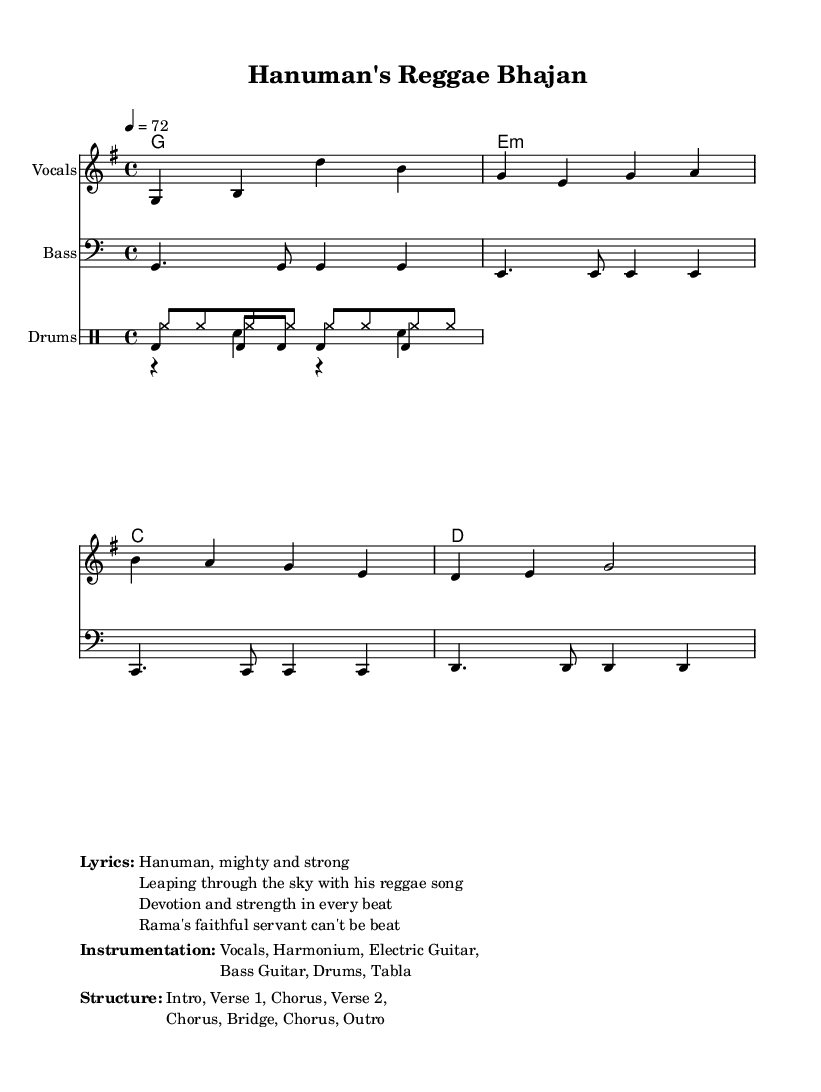What is the key signature of this music? The key signature is G major, which has one sharp (F#). It is indicated at the beginning of the staff in the sheet music.
Answer: G major What is the time signature of this music? The time signature is 4/4, meaning there are four beats in each measure and the quarter note gets one beat. This can be seen at the beginning of the music notation.
Answer: 4/4 What is the tempo marking of this piece? The tempo marking is 72 beats per minute, which is indicated in the tempo text at the top of the score. This shows the speed at which the piece should be played.
Answer: 72 How many measures are in the melody line? The melody line consists of 8 measures, as indicated by counting the distinct groupings of notes and rests in the melody section of the score.
Answer: 8 What type of instruments are used in this arrangement? The arrangement features vocals, harmonium, electric guitar, bass guitar, drums, and tabla. This is listed in the markup section below the score, detailing the instrumentation.
Answer: Vocals, Harmonium, Electric Guitar, Bass Guitar, Drums, Tabla What is the structure of the piece? The structure consists of an Intro, two Verses, a Chorus repeated multiple times, and an Outro. This is outlined in the markup section, which organizes the progression of the piece.
Answer: Intro, Verse 1, Chorus, Verse 2, Chorus, Bridge, Chorus, Outro What is the main theme of the lyrics? The main theme of the lyrics is devotion and strength through the character of Hanuman, who is celebrated for his loyalty and power. This can be inferred from the lyrics provided in the markup section.
Answer: Hanuman's strength and devotion 